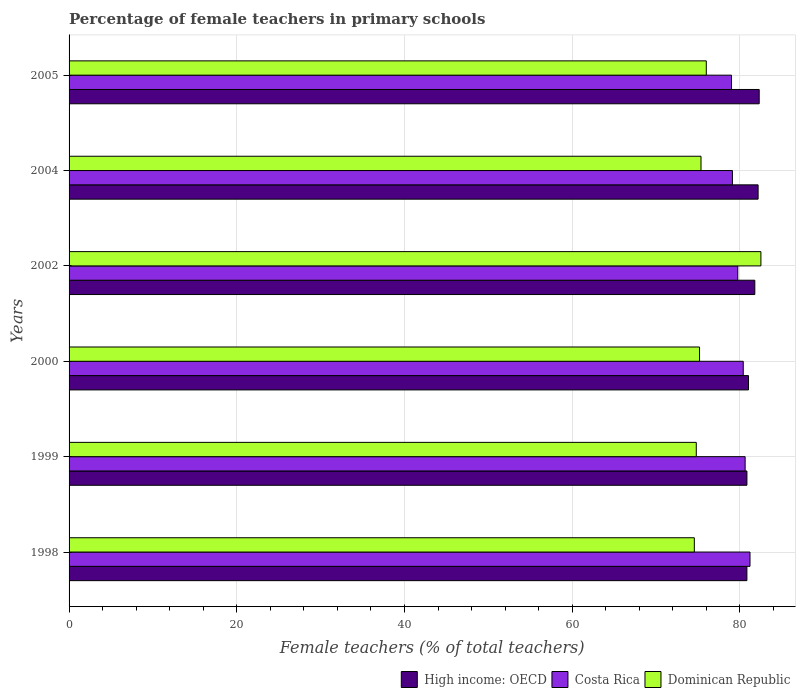How many groups of bars are there?
Offer a very short reply. 6. Are the number of bars on each tick of the Y-axis equal?
Offer a very short reply. Yes. What is the percentage of female teachers in High income: OECD in 2002?
Make the answer very short. 81.77. Across all years, what is the maximum percentage of female teachers in High income: OECD?
Your response must be concise. 82.29. Across all years, what is the minimum percentage of female teachers in Dominican Republic?
Provide a succinct answer. 74.56. In which year was the percentage of female teachers in Dominican Republic maximum?
Provide a short and direct response. 2002. In which year was the percentage of female teachers in Costa Rica minimum?
Your answer should be very brief. 2005. What is the total percentage of female teachers in Dominican Republic in the graph?
Your response must be concise. 458.35. What is the difference between the percentage of female teachers in Costa Rica in 2000 and that in 2005?
Your answer should be compact. 1.4. What is the difference between the percentage of female teachers in High income: OECD in 2005 and the percentage of female teachers in Costa Rica in 2000?
Keep it short and to the point. 1.9. What is the average percentage of female teachers in Costa Rica per year?
Give a very brief answer. 80. In the year 1998, what is the difference between the percentage of female teachers in Costa Rica and percentage of female teachers in High income: OECD?
Make the answer very short. 0.37. In how many years, is the percentage of female teachers in Dominican Republic greater than 8 %?
Provide a short and direct response. 6. What is the ratio of the percentage of female teachers in Costa Rica in 1998 to that in 1999?
Provide a short and direct response. 1.01. Is the difference between the percentage of female teachers in Costa Rica in 1999 and 2002 greater than the difference between the percentage of female teachers in High income: OECD in 1999 and 2002?
Provide a succinct answer. Yes. What is the difference between the highest and the second highest percentage of female teachers in Costa Rica?
Your answer should be very brief. 0.58. What is the difference between the highest and the lowest percentage of female teachers in High income: OECD?
Your answer should be compact. 1.47. In how many years, is the percentage of female teachers in Dominican Republic greater than the average percentage of female teachers in Dominican Republic taken over all years?
Your answer should be very brief. 1. Is the sum of the percentage of female teachers in Dominican Republic in 2000 and 2005 greater than the maximum percentage of female teachers in Costa Rica across all years?
Your answer should be very brief. Yes. What does the 3rd bar from the bottom in 2004 represents?
Give a very brief answer. Dominican Republic. Is it the case that in every year, the sum of the percentage of female teachers in High income: OECD and percentage of female teachers in Dominican Republic is greater than the percentage of female teachers in Costa Rica?
Offer a very short reply. Yes. How many bars are there?
Make the answer very short. 18. How many years are there in the graph?
Your response must be concise. 6. What is the difference between two consecutive major ticks on the X-axis?
Give a very brief answer. 20. Are the values on the major ticks of X-axis written in scientific E-notation?
Make the answer very short. No. What is the title of the graph?
Offer a terse response. Percentage of female teachers in primary schools. What is the label or title of the X-axis?
Offer a very short reply. Female teachers (% of total teachers). What is the Female teachers (% of total teachers) in High income: OECD in 1998?
Offer a terse response. 80.83. What is the Female teachers (% of total teachers) of Costa Rica in 1998?
Ensure brevity in your answer.  81.19. What is the Female teachers (% of total teachers) of Dominican Republic in 1998?
Ensure brevity in your answer.  74.56. What is the Female teachers (% of total teachers) in High income: OECD in 1999?
Provide a short and direct response. 80.83. What is the Female teachers (% of total teachers) of Costa Rica in 1999?
Ensure brevity in your answer.  80.62. What is the Female teachers (% of total teachers) in Dominican Republic in 1999?
Your response must be concise. 74.79. What is the Female teachers (% of total teachers) of High income: OECD in 2000?
Your response must be concise. 81.02. What is the Female teachers (% of total teachers) in Costa Rica in 2000?
Make the answer very short. 80.39. What is the Female teachers (% of total teachers) of Dominican Republic in 2000?
Your answer should be very brief. 75.18. What is the Female teachers (% of total teachers) in High income: OECD in 2002?
Offer a terse response. 81.77. What is the Female teachers (% of total teachers) in Costa Rica in 2002?
Ensure brevity in your answer.  79.74. What is the Female teachers (% of total teachers) in Dominican Republic in 2002?
Your answer should be compact. 82.49. What is the Female teachers (% of total teachers) of High income: OECD in 2004?
Ensure brevity in your answer.  82.16. What is the Female teachers (% of total teachers) in Costa Rica in 2004?
Your answer should be compact. 79.1. What is the Female teachers (% of total teachers) of Dominican Republic in 2004?
Offer a terse response. 75.35. What is the Female teachers (% of total teachers) of High income: OECD in 2005?
Your response must be concise. 82.29. What is the Female teachers (% of total teachers) in Costa Rica in 2005?
Keep it short and to the point. 78.99. What is the Female teachers (% of total teachers) of Dominican Republic in 2005?
Give a very brief answer. 75.98. Across all years, what is the maximum Female teachers (% of total teachers) of High income: OECD?
Offer a very short reply. 82.29. Across all years, what is the maximum Female teachers (% of total teachers) of Costa Rica?
Your response must be concise. 81.19. Across all years, what is the maximum Female teachers (% of total teachers) of Dominican Republic?
Your response must be concise. 82.49. Across all years, what is the minimum Female teachers (% of total teachers) of High income: OECD?
Keep it short and to the point. 80.83. Across all years, what is the minimum Female teachers (% of total teachers) of Costa Rica?
Your answer should be very brief. 78.99. Across all years, what is the minimum Female teachers (% of total teachers) in Dominican Republic?
Ensure brevity in your answer.  74.56. What is the total Female teachers (% of total teachers) in High income: OECD in the graph?
Offer a terse response. 488.89. What is the total Female teachers (% of total teachers) of Costa Rica in the graph?
Your answer should be very brief. 480.03. What is the total Female teachers (% of total teachers) of Dominican Republic in the graph?
Offer a very short reply. 458.35. What is the difference between the Female teachers (% of total teachers) in High income: OECD in 1998 and that in 1999?
Provide a succinct answer. -0. What is the difference between the Female teachers (% of total teachers) of Costa Rica in 1998 and that in 1999?
Ensure brevity in your answer.  0.58. What is the difference between the Female teachers (% of total teachers) of Dominican Republic in 1998 and that in 1999?
Offer a terse response. -0.23. What is the difference between the Female teachers (% of total teachers) in High income: OECD in 1998 and that in 2000?
Your answer should be compact. -0.19. What is the difference between the Female teachers (% of total teachers) of Costa Rica in 1998 and that in 2000?
Provide a succinct answer. 0.8. What is the difference between the Female teachers (% of total teachers) of Dominican Republic in 1998 and that in 2000?
Ensure brevity in your answer.  -0.62. What is the difference between the Female teachers (% of total teachers) of High income: OECD in 1998 and that in 2002?
Your answer should be compact. -0.94. What is the difference between the Female teachers (% of total teachers) in Costa Rica in 1998 and that in 2002?
Your answer should be very brief. 1.46. What is the difference between the Female teachers (% of total teachers) in Dominican Republic in 1998 and that in 2002?
Offer a terse response. -7.94. What is the difference between the Female teachers (% of total teachers) of High income: OECD in 1998 and that in 2004?
Provide a succinct answer. -1.34. What is the difference between the Female teachers (% of total teachers) of Costa Rica in 1998 and that in 2004?
Give a very brief answer. 2.1. What is the difference between the Female teachers (% of total teachers) in Dominican Republic in 1998 and that in 2004?
Keep it short and to the point. -0.8. What is the difference between the Female teachers (% of total teachers) in High income: OECD in 1998 and that in 2005?
Provide a short and direct response. -1.47. What is the difference between the Female teachers (% of total teachers) in Costa Rica in 1998 and that in 2005?
Your answer should be very brief. 2.2. What is the difference between the Female teachers (% of total teachers) in Dominican Republic in 1998 and that in 2005?
Keep it short and to the point. -1.43. What is the difference between the Female teachers (% of total teachers) of High income: OECD in 1999 and that in 2000?
Your answer should be compact. -0.19. What is the difference between the Female teachers (% of total teachers) of Costa Rica in 1999 and that in 2000?
Give a very brief answer. 0.23. What is the difference between the Female teachers (% of total teachers) in Dominican Republic in 1999 and that in 2000?
Make the answer very short. -0.39. What is the difference between the Female teachers (% of total teachers) of High income: OECD in 1999 and that in 2002?
Give a very brief answer. -0.94. What is the difference between the Female teachers (% of total teachers) of Costa Rica in 1999 and that in 2002?
Your answer should be very brief. 0.88. What is the difference between the Female teachers (% of total teachers) of Dominican Republic in 1999 and that in 2002?
Provide a short and direct response. -7.71. What is the difference between the Female teachers (% of total teachers) in High income: OECD in 1999 and that in 2004?
Make the answer very short. -1.33. What is the difference between the Female teachers (% of total teachers) in Costa Rica in 1999 and that in 2004?
Your answer should be very brief. 1.52. What is the difference between the Female teachers (% of total teachers) of Dominican Republic in 1999 and that in 2004?
Provide a short and direct response. -0.56. What is the difference between the Female teachers (% of total teachers) of High income: OECD in 1999 and that in 2005?
Your answer should be very brief. -1.47. What is the difference between the Female teachers (% of total teachers) of Costa Rica in 1999 and that in 2005?
Keep it short and to the point. 1.62. What is the difference between the Female teachers (% of total teachers) of Dominican Republic in 1999 and that in 2005?
Provide a short and direct response. -1.2. What is the difference between the Female teachers (% of total teachers) in High income: OECD in 2000 and that in 2002?
Make the answer very short. -0.75. What is the difference between the Female teachers (% of total teachers) in Costa Rica in 2000 and that in 2002?
Your answer should be compact. 0.65. What is the difference between the Female teachers (% of total teachers) in Dominican Republic in 2000 and that in 2002?
Offer a terse response. -7.32. What is the difference between the Female teachers (% of total teachers) in High income: OECD in 2000 and that in 2004?
Offer a very short reply. -1.14. What is the difference between the Female teachers (% of total teachers) of Costa Rica in 2000 and that in 2004?
Keep it short and to the point. 1.29. What is the difference between the Female teachers (% of total teachers) of Dominican Republic in 2000 and that in 2004?
Give a very brief answer. -0.17. What is the difference between the Female teachers (% of total teachers) in High income: OECD in 2000 and that in 2005?
Give a very brief answer. -1.27. What is the difference between the Female teachers (% of total teachers) in Costa Rica in 2000 and that in 2005?
Your answer should be very brief. 1.4. What is the difference between the Female teachers (% of total teachers) in Dominican Republic in 2000 and that in 2005?
Offer a very short reply. -0.81. What is the difference between the Female teachers (% of total teachers) in High income: OECD in 2002 and that in 2004?
Give a very brief answer. -0.39. What is the difference between the Female teachers (% of total teachers) of Costa Rica in 2002 and that in 2004?
Your response must be concise. 0.64. What is the difference between the Female teachers (% of total teachers) of Dominican Republic in 2002 and that in 2004?
Give a very brief answer. 7.14. What is the difference between the Female teachers (% of total teachers) in High income: OECD in 2002 and that in 2005?
Keep it short and to the point. -0.52. What is the difference between the Female teachers (% of total teachers) of Costa Rica in 2002 and that in 2005?
Make the answer very short. 0.75. What is the difference between the Female teachers (% of total teachers) of Dominican Republic in 2002 and that in 2005?
Your answer should be very brief. 6.51. What is the difference between the Female teachers (% of total teachers) of High income: OECD in 2004 and that in 2005?
Ensure brevity in your answer.  -0.13. What is the difference between the Female teachers (% of total teachers) in Costa Rica in 2004 and that in 2005?
Offer a very short reply. 0.11. What is the difference between the Female teachers (% of total teachers) of Dominican Republic in 2004 and that in 2005?
Make the answer very short. -0.63. What is the difference between the Female teachers (% of total teachers) in High income: OECD in 1998 and the Female teachers (% of total teachers) in Costa Rica in 1999?
Your answer should be compact. 0.21. What is the difference between the Female teachers (% of total teachers) in High income: OECD in 1998 and the Female teachers (% of total teachers) in Dominican Republic in 1999?
Offer a terse response. 6.04. What is the difference between the Female teachers (% of total teachers) in Costa Rica in 1998 and the Female teachers (% of total teachers) in Dominican Republic in 1999?
Offer a very short reply. 6.41. What is the difference between the Female teachers (% of total teachers) in High income: OECD in 1998 and the Female teachers (% of total teachers) in Costa Rica in 2000?
Offer a terse response. 0.44. What is the difference between the Female teachers (% of total teachers) of High income: OECD in 1998 and the Female teachers (% of total teachers) of Dominican Republic in 2000?
Your answer should be compact. 5.65. What is the difference between the Female teachers (% of total teachers) of Costa Rica in 1998 and the Female teachers (% of total teachers) of Dominican Republic in 2000?
Your response must be concise. 6.02. What is the difference between the Female teachers (% of total teachers) in High income: OECD in 1998 and the Female teachers (% of total teachers) in Costa Rica in 2002?
Your answer should be very brief. 1.09. What is the difference between the Female teachers (% of total teachers) in High income: OECD in 1998 and the Female teachers (% of total teachers) in Dominican Republic in 2002?
Your answer should be compact. -1.67. What is the difference between the Female teachers (% of total teachers) of Costa Rica in 1998 and the Female teachers (% of total teachers) of Dominican Republic in 2002?
Make the answer very short. -1.3. What is the difference between the Female teachers (% of total teachers) in High income: OECD in 1998 and the Female teachers (% of total teachers) in Costa Rica in 2004?
Make the answer very short. 1.73. What is the difference between the Female teachers (% of total teachers) of High income: OECD in 1998 and the Female teachers (% of total teachers) of Dominican Republic in 2004?
Give a very brief answer. 5.47. What is the difference between the Female teachers (% of total teachers) of Costa Rica in 1998 and the Female teachers (% of total teachers) of Dominican Republic in 2004?
Ensure brevity in your answer.  5.84. What is the difference between the Female teachers (% of total teachers) in High income: OECD in 1998 and the Female teachers (% of total teachers) in Costa Rica in 2005?
Your response must be concise. 1.83. What is the difference between the Female teachers (% of total teachers) of High income: OECD in 1998 and the Female teachers (% of total teachers) of Dominican Republic in 2005?
Make the answer very short. 4.84. What is the difference between the Female teachers (% of total teachers) of Costa Rica in 1998 and the Female teachers (% of total teachers) of Dominican Republic in 2005?
Ensure brevity in your answer.  5.21. What is the difference between the Female teachers (% of total teachers) of High income: OECD in 1999 and the Female teachers (% of total teachers) of Costa Rica in 2000?
Your response must be concise. 0.44. What is the difference between the Female teachers (% of total teachers) in High income: OECD in 1999 and the Female teachers (% of total teachers) in Dominican Republic in 2000?
Provide a short and direct response. 5.65. What is the difference between the Female teachers (% of total teachers) in Costa Rica in 1999 and the Female teachers (% of total teachers) in Dominican Republic in 2000?
Keep it short and to the point. 5.44. What is the difference between the Female teachers (% of total teachers) in High income: OECD in 1999 and the Female teachers (% of total teachers) in Costa Rica in 2002?
Provide a succinct answer. 1.09. What is the difference between the Female teachers (% of total teachers) in High income: OECD in 1999 and the Female teachers (% of total teachers) in Dominican Republic in 2002?
Ensure brevity in your answer.  -1.67. What is the difference between the Female teachers (% of total teachers) of Costa Rica in 1999 and the Female teachers (% of total teachers) of Dominican Republic in 2002?
Provide a short and direct response. -1.88. What is the difference between the Female teachers (% of total teachers) of High income: OECD in 1999 and the Female teachers (% of total teachers) of Costa Rica in 2004?
Keep it short and to the point. 1.73. What is the difference between the Female teachers (% of total teachers) in High income: OECD in 1999 and the Female teachers (% of total teachers) in Dominican Republic in 2004?
Your answer should be compact. 5.48. What is the difference between the Female teachers (% of total teachers) in Costa Rica in 1999 and the Female teachers (% of total teachers) in Dominican Republic in 2004?
Offer a terse response. 5.26. What is the difference between the Female teachers (% of total teachers) in High income: OECD in 1999 and the Female teachers (% of total teachers) in Costa Rica in 2005?
Your answer should be very brief. 1.84. What is the difference between the Female teachers (% of total teachers) in High income: OECD in 1999 and the Female teachers (% of total teachers) in Dominican Republic in 2005?
Make the answer very short. 4.84. What is the difference between the Female teachers (% of total teachers) of Costa Rica in 1999 and the Female teachers (% of total teachers) of Dominican Republic in 2005?
Provide a short and direct response. 4.63. What is the difference between the Female teachers (% of total teachers) in High income: OECD in 2000 and the Female teachers (% of total teachers) in Costa Rica in 2002?
Keep it short and to the point. 1.28. What is the difference between the Female teachers (% of total teachers) in High income: OECD in 2000 and the Female teachers (% of total teachers) in Dominican Republic in 2002?
Your answer should be compact. -1.48. What is the difference between the Female teachers (% of total teachers) in Costa Rica in 2000 and the Female teachers (% of total teachers) in Dominican Republic in 2002?
Provide a short and direct response. -2.1. What is the difference between the Female teachers (% of total teachers) in High income: OECD in 2000 and the Female teachers (% of total teachers) in Costa Rica in 2004?
Offer a terse response. 1.92. What is the difference between the Female teachers (% of total teachers) in High income: OECD in 2000 and the Female teachers (% of total teachers) in Dominican Republic in 2004?
Make the answer very short. 5.67. What is the difference between the Female teachers (% of total teachers) of Costa Rica in 2000 and the Female teachers (% of total teachers) of Dominican Republic in 2004?
Provide a short and direct response. 5.04. What is the difference between the Female teachers (% of total teachers) in High income: OECD in 2000 and the Female teachers (% of total teachers) in Costa Rica in 2005?
Make the answer very short. 2.03. What is the difference between the Female teachers (% of total teachers) of High income: OECD in 2000 and the Female teachers (% of total teachers) of Dominican Republic in 2005?
Ensure brevity in your answer.  5.03. What is the difference between the Female teachers (% of total teachers) of Costa Rica in 2000 and the Female teachers (% of total teachers) of Dominican Republic in 2005?
Your response must be concise. 4.41. What is the difference between the Female teachers (% of total teachers) in High income: OECD in 2002 and the Female teachers (% of total teachers) in Costa Rica in 2004?
Your answer should be very brief. 2.67. What is the difference between the Female teachers (% of total teachers) of High income: OECD in 2002 and the Female teachers (% of total teachers) of Dominican Republic in 2004?
Your answer should be very brief. 6.42. What is the difference between the Female teachers (% of total teachers) in Costa Rica in 2002 and the Female teachers (% of total teachers) in Dominican Republic in 2004?
Offer a very short reply. 4.38. What is the difference between the Female teachers (% of total teachers) of High income: OECD in 2002 and the Female teachers (% of total teachers) of Costa Rica in 2005?
Give a very brief answer. 2.78. What is the difference between the Female teachers (% of total teachers) of High income: OECD in 2002 and the Female teachers (% of total teachers) of Dominican Republic in 2005?
Ensure brevity in your answer.  5.78. What is the difference between the Female teachers (% of total teachers) of Costa Rica in 2002 and the Female teachers (% of total teachers) of Dominican Republic in 2005?
Your response must be concise. 3.75. What is the difference between the Female teachers (% of total teachers) in High income: OECD in 2004 and the Female teachers (% of total teachers) in Costa Rica in 2005?
Offer a very short reply. 3.17. What is the difference between the Female teachers (% of total teachers) of High income: OECD in 2004 and the Female teachers (% of total teachers) of Dominican Republic in 2005?
Give a very brief answer. 6.18. What is the difference between the Female teachers (% of total teachers) of Costa Rica in 2004 and the Female teachers (% of total teachers) of Dominican Republic in 2005?
Offer a very short reply. 3.11. What is the average Female teachers (% of total teachers) in High income: OECD per year?
Keep it short and to the point. 81.48. What is the average Female teachers (% of total teachers) of Costa Rica per year?
Your response must be concise. 80. What is the average Female teachers (% of total teachers) of Dominican Republic per year?
Your answer should be very brief. 76.39. In the year 1998, what is the difference between the Female teachers (% of total teachers) in High income: OECD and Female teachers (% of total teachers) in Costa Rica?
Provide a short and direct response. -0.37. In the year 1998, what is the difference between the Female teachers (% of total teachers) of High income: OECD and Female teachers (% of total teachers) of Dominican Republic?
Offer a very short reply. 6.27. In the year 1998, what is the difference between the Female teachers (% of total teachers) in Costa Rica and Female teachers (% of total teachers) in Dominican Republic?
Provide a short and direct response. 6.64. In the year 1999, what is the difference between the Female teachers (% of total teachers) in High income: OECD and Female teachers (% of total teachers) in Costa Rica?
Offer a terse response. 0.21. In the year 1999, what is the difference between the Female teachers (% of total teachers) in High income: OECD and Female teachers (% of total teachers) in Dominican Republic?
Make the answer very short. 6.04. In the year 1999, what is the difference between the Female teachers (% of total teachers) of Costa Rica and Female teachers (% of total teachers) of Dominican Republic?
Your answer should be compact. 5.83. In the year 2000, what is the difference between the Female teachers (% of total teachers) in High income: OECD and Female teachers (% of total teachers) in Costa Rica?
Keep it short and to the point. 0.63. In the year 2000, what is the difference between the Female teachers (% of total teachers) of High income: OECD and Female teachers (% of total teachers) of Dominican Republic?
Your answer should be compact. 5.84. In the year 2000, what is the difference between the Female teachers (% of total teachers) in Costa Rica and Female teachers (% of total teachers) in Dominican Republic?
Keep it short and to the point. 5.21. In the year 2002, what is the difference between the Female teachers (% of total teachers) of High income: OECD and Female teachers (% of total teachers) of Costa Rica?
Provide a succinct answer. 2.03. In the year 2002, what is the difference between the Female teachers (% of total teachers) in High income: OECD and Female teachers (% of total teachers) in Dominican Republic?
Your answer should be compact. -0.73. In the year 2002, what is the difference between the Female teachers (% of total teachers) in Costa Rica and Female teachers (% of total teachers) in Dominican Republic?
Your answer should be compact. -2.76. In the year 2004, what is the difference between the Female teachers (% of total teachers) of High income: OECD and Female teachers (% of total teachers) of Costa Rica?
Keep it short and to the point. 3.06. In the year 2004, what is the difference between the Female teachers (% of total teachers) of High income: OECD and Female teachers (% of total teachers) of Dominican Republic?
Ensure brevity in your answer.  6.81. In the year 2004, what is the difference between the Female teachers (% of total teachers) in Costa Rica and Female teachers (% of total teachers) in Dominican Republic?
Offer a terse response. 3.75. In the year 2005, what is the difference between the Female teachers (% of total teachers) in High income: OECD and Female teachers (% of total teachers) in Costa Rica?
Make the answer very short. 3.3. In the year 2005, what is the difference between the Female teachers (% of total teachers) of High income: OECD and Female teachers (% of total teachers) of Dominican Republic?
Your answer should be compact. 6.31. In the year 2005, what is the difference between the Female teachers (% of total teachers) in Costa Rica and Female teachers (% of total teachers) in Dominican Republic?
Make the answer very short. 3.01. What is the ratio of the Female teachers (% of total teachers) in High income: OECD in 1998 to that in 1999?
Your response must be concise. 1. What is the ratio of the Female teachers (% of total teachers) of High income: OECD in 1998 to that in 2000?
Keep it short and to the point. 1. What is the ratio of the Female teachers (% of total teachers) in Costa Rica in 1998 to that in 2002?
Your answer should be compact. 1.02. What is the ratio of the Female teachers (% of total teachers) of Dominican Republic in 1998 to that in 2002?
Provide a short and direct response. 0.9. What is the ratio of the Female teachers (% of total teachers) of High income: OECD in 1998 to that in 2004?
Offer a terse response. 0.98. What is the ratio of the Female teachers (% of total teachers) in Costa Rica in 1998 to that in 2004?
Offer a very short reply. 1.03. What is the ratio of the Female teachers (% of total teachers) of High income: OECD in 1998 to that in 2005?
Keep it short and to the point. 0.98. What is the ratio of the Female teachers (% of total teachers) in Costa Rica in 1998 to that in 2005?
Give a very brief answer. 1.03. What is the ratio of the Female teachers (% of total teachers) in Dominican Republic in 1998 to that in 2005?
Give a very brief answer. 0.98. What is the ratio of the Female teachers (% of total teachers) of Dominican Republic in 1999 to that in 2000?
Give a very brief answer. 0.99. What is the ratio of the Female teachers (% of total teachers) of High income: OECD in 1999 to that in 2002?
Make the answer very short. 0.99. What is the ratio of the Female teachers (% of total teachers) of Costa Rica in 1999 to that in 2002?
Provide a succinct answer. 1.01. What is the ratio of the Female teachers (% of total teachers) in Dominican Republic in 1999 to that in 2002?
Keep it short and to the point. 0.91. What is the ratio of the Female teachers (% of total teachers) in High income: OECD in 1999 to that in 2004?
Keep it short and to the point. 0.98. What is the ratio of the Female teachers (% of total teachers) of Costa Rica in 1999 to that in 2004?
Keep it short and to the point. 1.02. What is the ratio of the Female teachers (% of total teachers) of High income: OECD in 1999 to that in 2005?
Give a very brief answer. 0.98. What is the ratio of the Female teachers (% of total teachers) in Costa Rica in 1999 to that in 2005?
Keep it short and to the point. 1.02. What is the ratio of the Female teachers (% of total teachers) in Dominican Republic in 1999 to that in 2005?
Your answer should be compact. 0.98. What is the ratio of the Female teachers (% of total teachers) in High income: OECD in 2000 to that in 2002?
Provide a short and direct response. 0.99. What is the ratio of the Female teachers (% of total teachers) in Costa Rica in 2000 to that in 2002?
Provide a short and direct response. 1.01. What is the ratio of the Female teachers (% of total teachers) of Dominican Republic in 2000 to that in 2002?
Your answer should be very brief. 0.91. What is the ratio of the Female teachers (% of total teachers) in High income: OECD in 2000 to that in 2004?
Keep it short and to the point. 0.99. What is the ratio of the Female teachers (% of total teachers) in Costa Rica in 2000 to that in 2004?
Offer a terse response. 1.02. What is the ratio of the Female teachers (% of total teachers) in Dominican Republic in 2000 to that in 2004?
Your answer should be very brief. 1. What is the ratio of the Female teachers (% of total teachers) of High income: OECD in 2000 to that in 2005?
Ensure brevity in your answer.  0.98. What is the ratio of the Female teachers (% of total teachers) of Costa Rica in 2000 to that in 2005?
Your answer should be compact. 1.02. What is the ratio of the Female teachers (% of total teachers) of Dominican Republic in 2000 to that in 2005?
Your answer should be very brief. 0.99. What is the ratio of the Female teachers (% of total teachers) of High income: OECD in 2002 to that in 2004?
Provide a short and direct response. 1. What is the ratio of the Female teachers (% of total teachers) in Costa Rica in 2002 to that in 2004?
Ensure brevity in your answer.  1.01. What is the ratio of the Female teachers (% of total teachers) in Dominican Republic in 2002 to that in 2004?
Ensure brevity in your answer.  1.09. What is the ratio of the Female teachers (% of total teachers) in High income: OECD in 2002 to that in 2005?
Offer a terse response. 0.99. What is the ratio of the Female teachers (% of total teachers) in Costa Rica in 2002 to that in 2005?
Provide a succinct answer. 1.01. What is the ratio of the Female teachers (% of total teachers) in Dominican Republic in 2002 to that in 2005?
Keep it short and to the point. 1.09. What is the ratio of the Female teachers (% of total teachers) in High income: OECD in 2004 to that in 2005?
Your answer should be very brief. 1. What is the difference between the highest and the second highest Female teachers (% of total teachers) in High income: OECD?
Your response must be concise. 0.13. What is the difference between the highest and the second highest Female teachers (% of total teachers) in Costa Rica?
Keep it short and to the point. 0.58. What is the difference between the highest and the second highest Female teachers (% of total teachers) of Dominican Republic?
Your answer should be compact. 6.51. What is the difference between the highest and the lowest Female teachers (% of total teachers) in High income: OECD?
Provide a succinct answer. 1.47. What is the difference between the highest and the lowest Female teachers (% of total teachers) in Costa Rica?
Offer a terse response. 2.2. What is the difference between the highest and the lowest Female teachers (% of total teachers) of Dominican Republic?
Offer a very short reply. 7.94. 